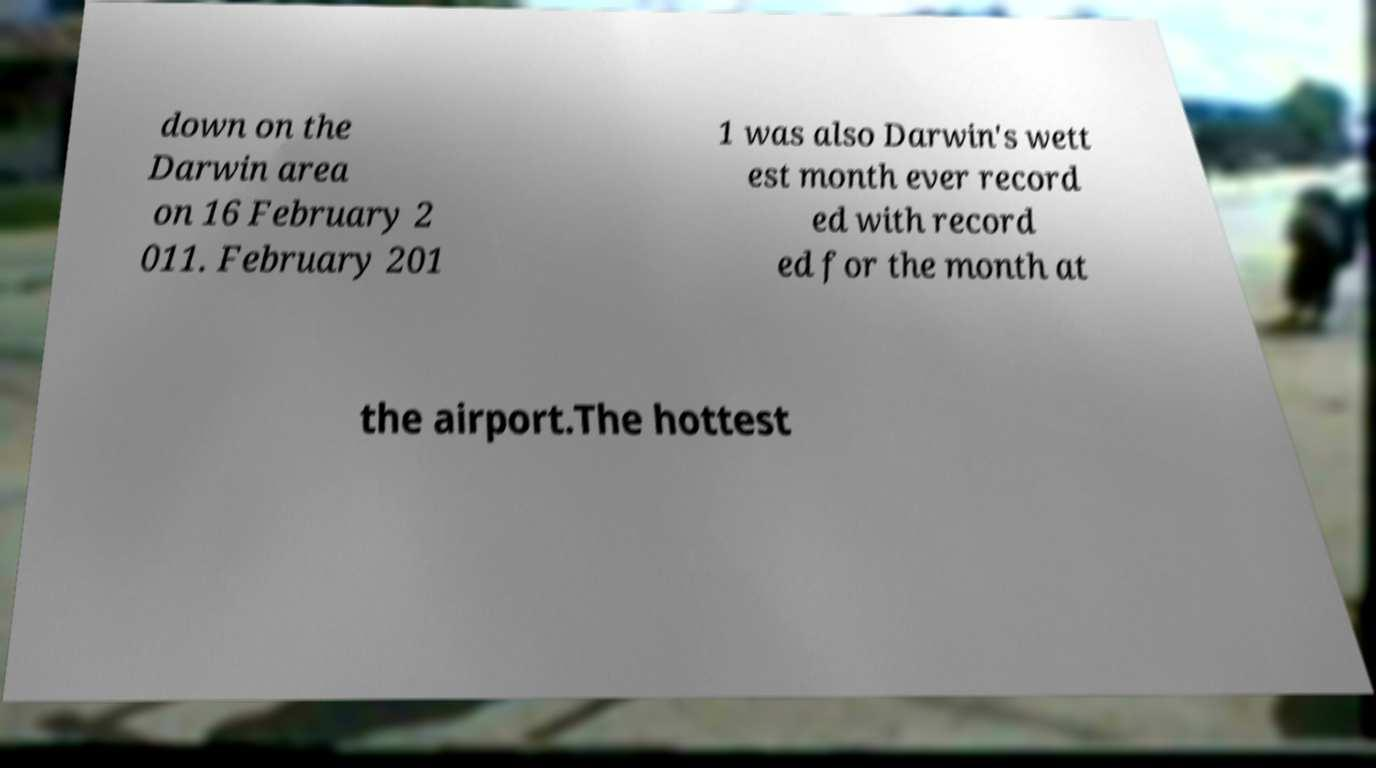Please read and relay the text visible in this image. What does it say? down on the Darwin area on 16 February 2 011. February 201 1 was also Darwin's wett est month ever record ed with record ed for the month at the airport.The hottest 